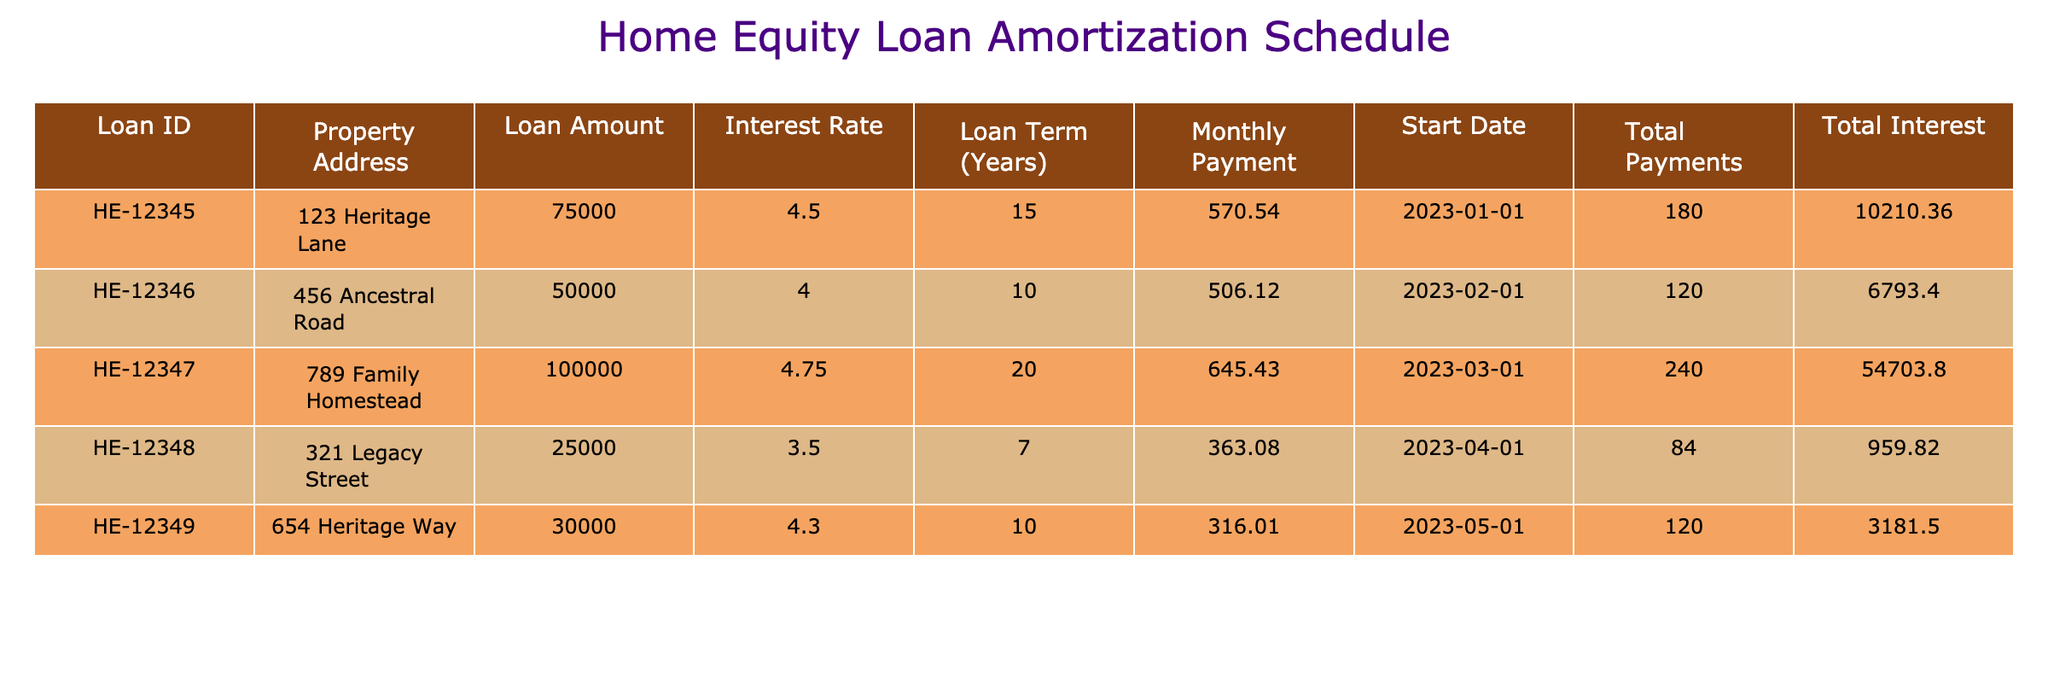What's the loan amount for the property at 123 Heritage Lane? The table shows the loan amount for each property. For the property at 123 Heritage Lane, the loan amount is listed directly in the table as 75000.
Answer: 75000 What is the total interest for the loan on 456 Ancestral Road? The total interest for each loan is detailed in the table. For 456 Ancestral Road, the total interest amount is 6793.40.
Answer: 6793.40 Which property has the longest loan term and how many years is it? To find the longest loan term, I will look through the "Loan Term (Years)" column. The property at 789 Family Homestead has a loan term of 20 years, which is the greatest value in that column.
Answer: 20 years What is the average monthly payment for all the loans? I will calculate the average monthly payment by summing all monthly payments and dividing by the number of loans. The total monthly payments are (570.54 + 506.12 + 645.43 + 363.08 + 316.01) = 2401.18. There are 5 loans, so the average is 2401.18 / 5 = 480.24.
Answer: 480.24 Does the property at 321 Legacy Street have a higher loan amount than the property at 654 Heritage Way? I will compare the loan amounts for both properties. The loan amount for 321 Legacy Street is 25000 and for 654 Heritage Way it is 30000. Since 25000 is less than 30000, the answer is no.
Answer: No What is the total amount of all loans taken? I will sum up all the loan amounts to find the total. The total is (75000 + 50000 + 100000 + 25000 + 30000) = 300000.
Answer: 300000 Are there more loans with interest rates above 4.5% than below? I will check the interest rates. The loans with rates above 4.5% are for properties 789 Family Homestead (4.75), while the others are below 4.5%. There is only one loan above 4.5% and four below, so the answer is no.
Answer: No What is the difference in total payments between the loan at 123 Heritage Lane and the loan at 456 Ancestral Road? To find the difference, I will take the total payments of each loan: for 123 Heritage Lane, it's 180, and for 456 Ancestral Road, it's 120. Therefore, the difference is 180 - 120 = 60.
Answer: 60 Which property has the lowest monthly payment, and what is that payment? I will review the "Monthly Payment" column to find the lowest value. The lowest monthly payment is for the property at 321 Legacy Street, which is 363.08.
Answer: 363.08 